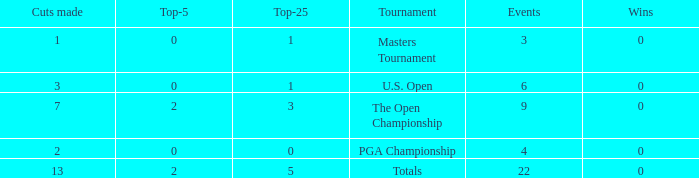What is the average number of cuts made for events with 0 top-5s? None. 